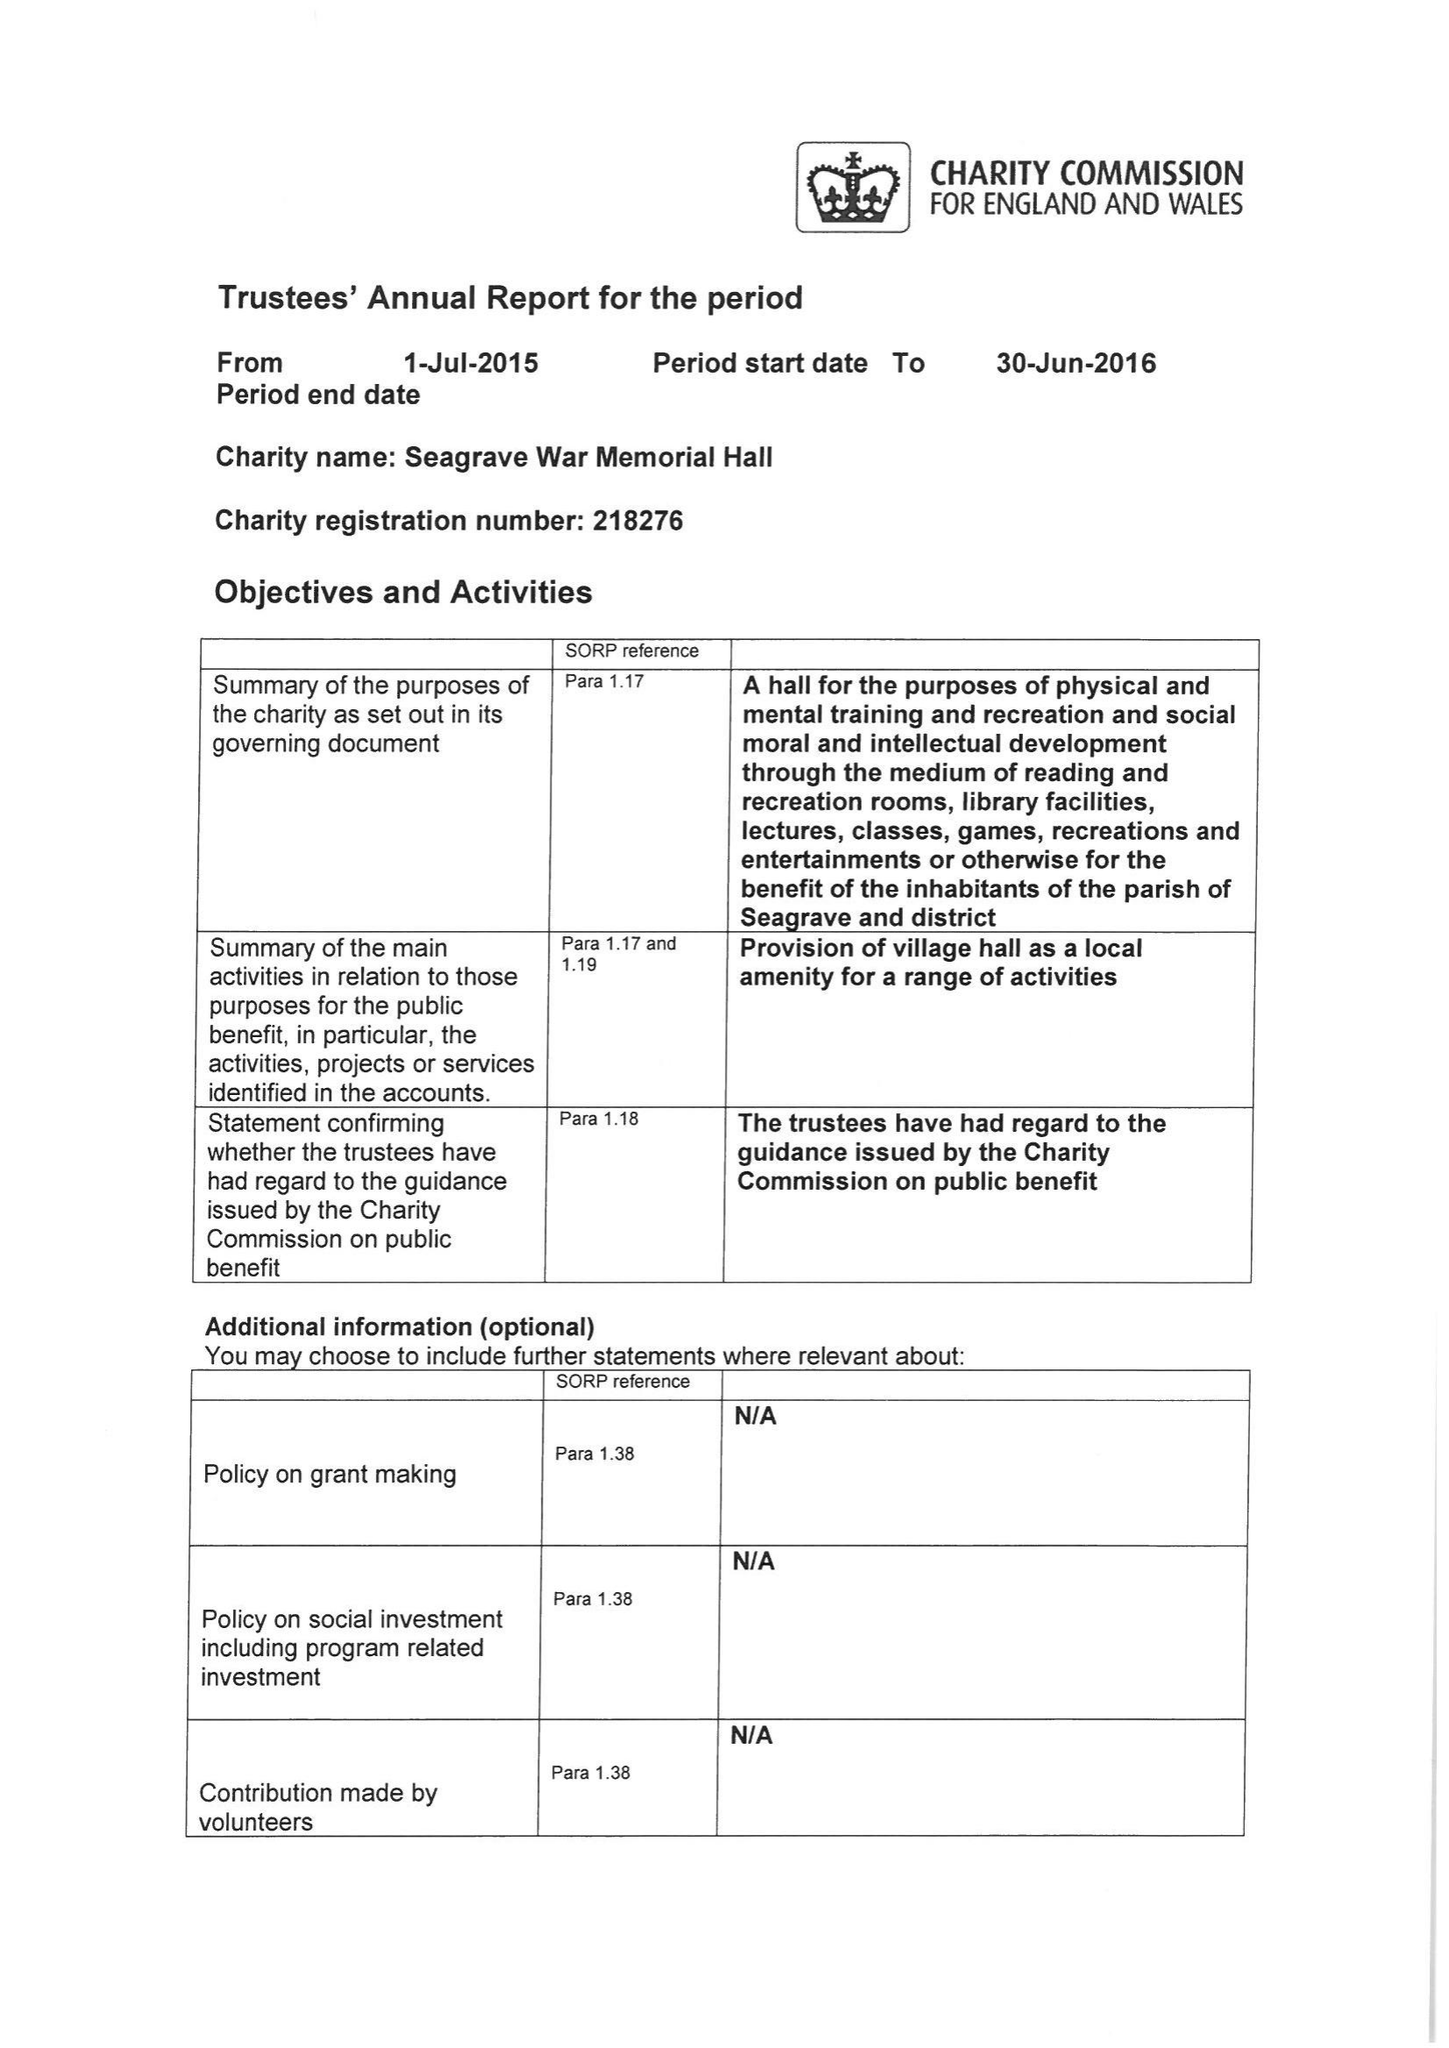What is the value for the address__postcode?
Answer the question using a single word or phrase. LE12 7LU 